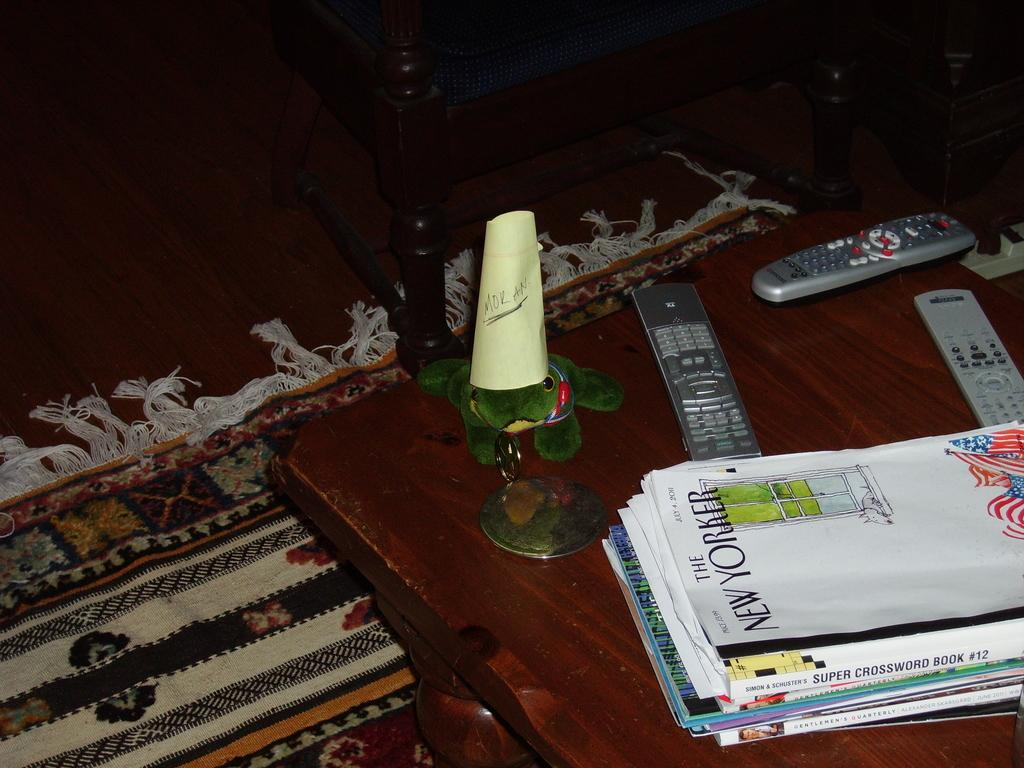<image>
Give a short and clear explanation of the subsequent image. stacks of magazines on a table with a candle and remote controls, the top magazine says The New Yorker. 